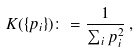Convert formula to latex. <formula><loc_0><loc_0><loc_500><loc_500>K ( \{ p _ { i } \} ) \colon = \frac { 1 } { \sum _ { i } p _ { i } ^ { 2 } } \, ,</formula> 